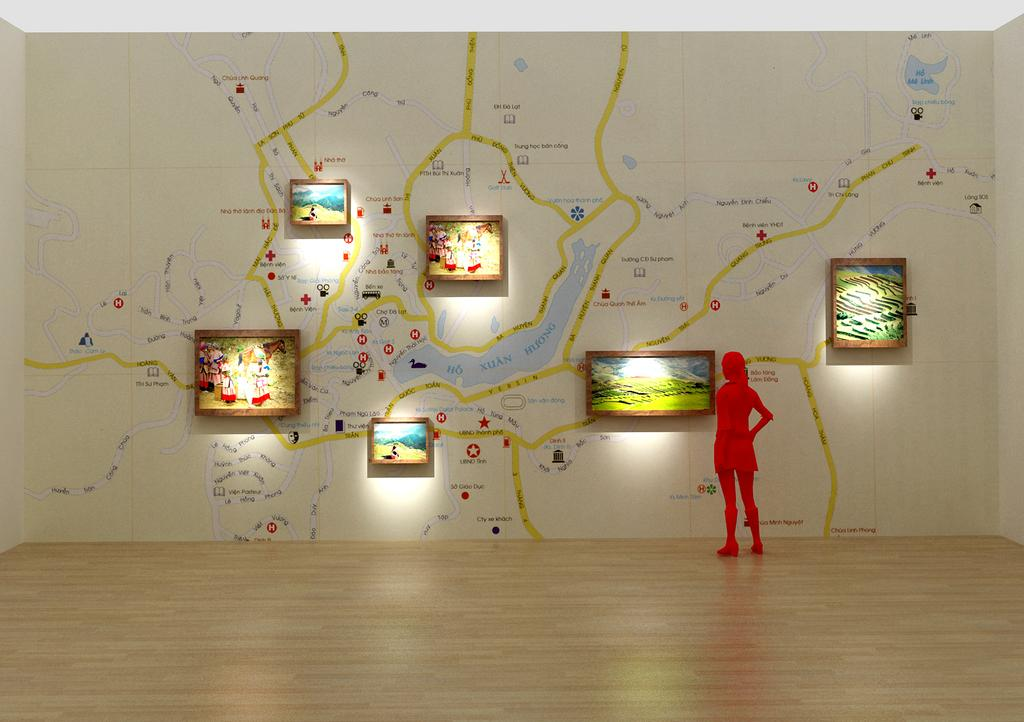Who is the main subject in the image? There is a woman standing in the front of the image. What can be seen in the background of the image? There are frames and a painting on the wall in the background of the image. What word is written on the mailbox in the image? There is no mailbox present in the image. What type of disease is the woman suffering from in the image? There is no indication of any disease in the image; the woman is simply standing in the front. 